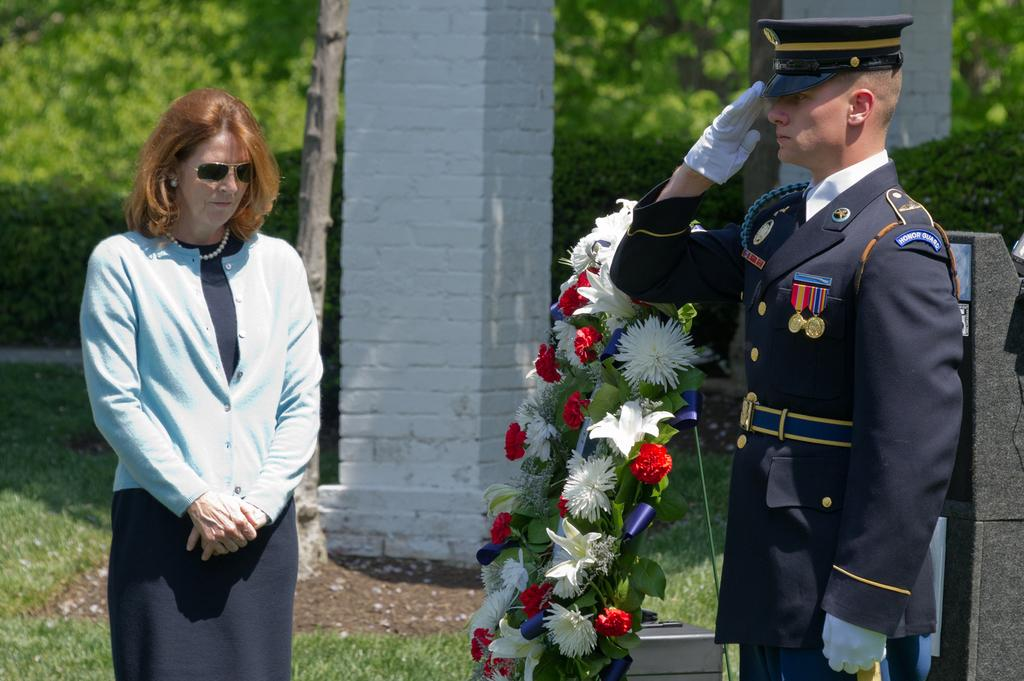Who is on the left side of the image? There is a woman standing on the left side of the image. Who is on the right side of the image? There is a man wearing a uniform on the right side of the image. What can be seen in the background of the image? There are white pillars and trees in the background of the image. What type of egg is being used as a prop in the image? There is no egg present in the image. Can you describe the map that the woman is holding in the image? There is no map present in the image; the woman is not holding anything. 